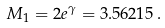Convert formula to latex. <formula><loc_0><loc_0><loc_500><loc_500>M _ { 1 } = 2 e ^ { \gamma } = 3 . 5 6 2 1 5 \, .</formula> 